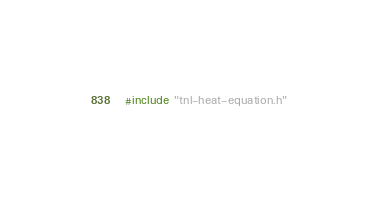Convert code to text. <code><loc_0><loc_0><loc_500><loc_500><_Cuda_>#include "tnl-heat-equation.h"
</code> 